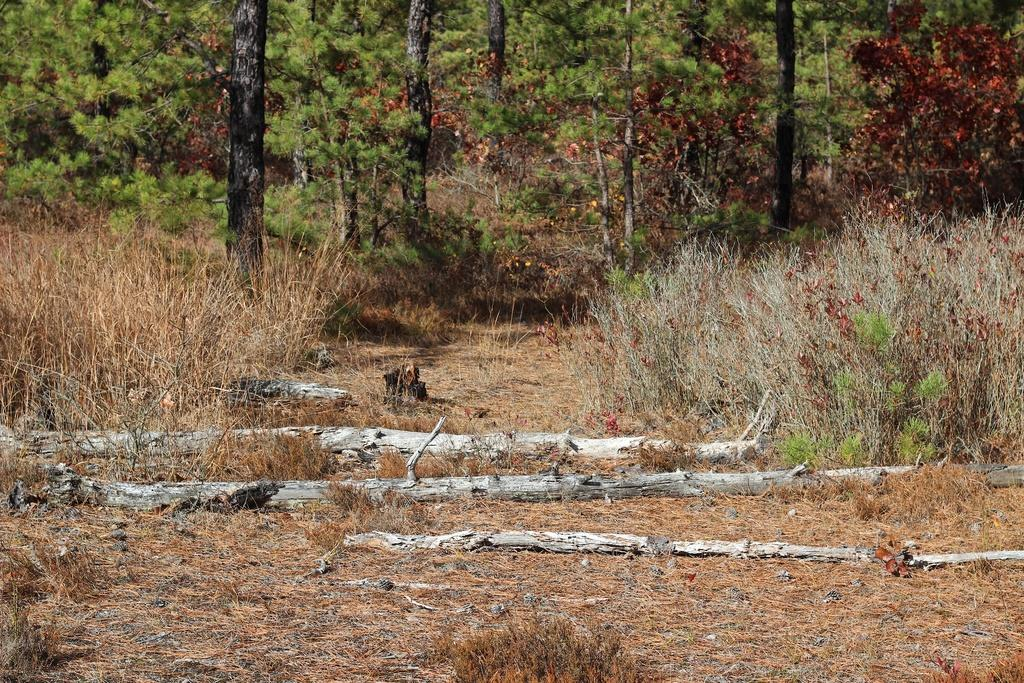What type of vegetation can be seen in the image? There are trees, plants, and grass in the image. Are there any fallen trees in the image? Yes, some trees have fallen down on the ground in the image. What type of verse can be seen written on the fallen trees in the image? There is no verse written on the fallen trees in the image; the image only shows trees, plants, and grass. 